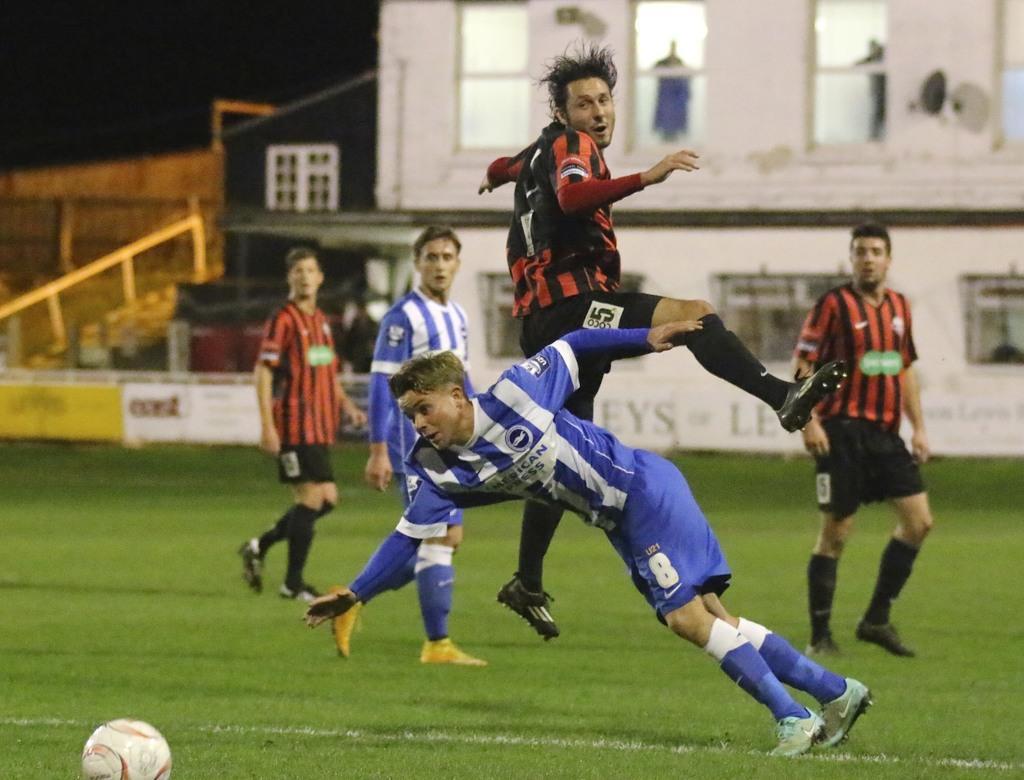Could you give a brief overview of what you see in this image? In this image there are a few players playing on the surface of the grass and there is a ball. In the background there is a building and few people are standing in the balcony. On the left side of the image there are stairs. 